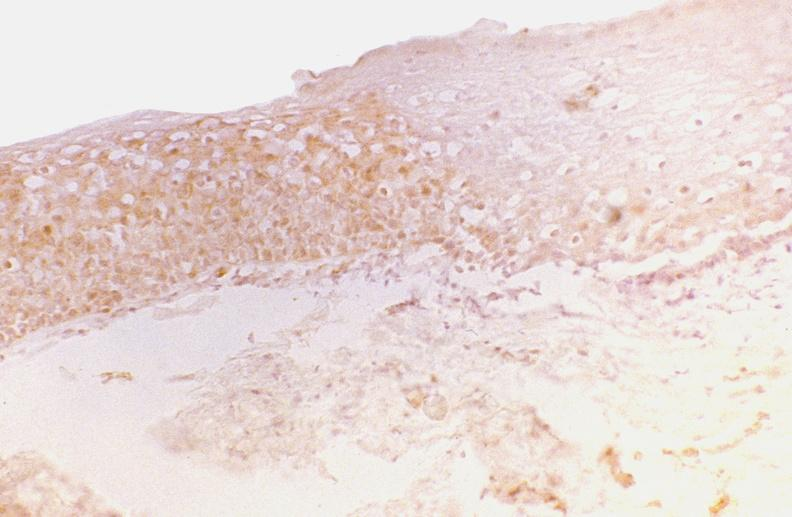what does this image show?
Answer the question using a single word or phrase. Oral dysplasia 